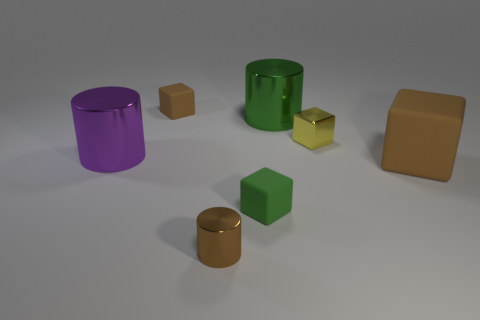Subtract all large cylinders. How many cylinders are left? 1 Subtract all yellow cylinders. How many brown blocks are left? 2 Subtract 2 blocks. How many blocks are left? 2 Add 1 blocks. How many objects exist? 8 Subtract all green cubes. How many cubes are left? 3 Subtract all red cylinders. Subtract all green spheres. How many cylinders are left? 3 Subtract all tiny brown cylinders. Subtract all tiny metal cylinders. How many objects are left? 5 Add 6 small yellow things. How many small yellow things are left? 7 Add 1 tiny brown cylinders. How many tiny brown cylinders exist? 2 Subtract 0 yellow cylinders. How many objects are left? 7 